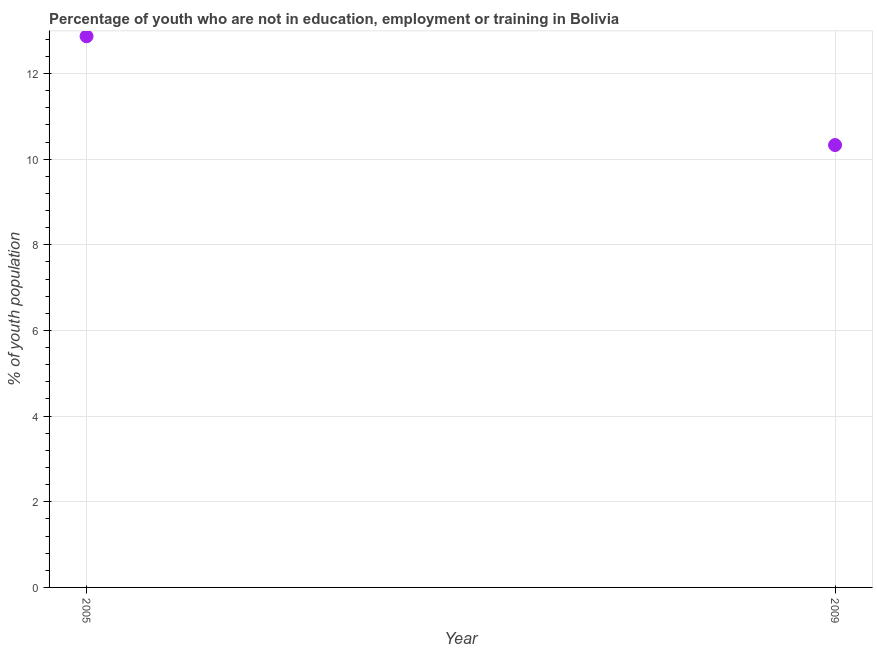What is the unemployed youth population in 2005?
Offer a very short reply. 12.87. Across all years, what is the maximum unemployed youth population?
Ensure brevity in your answer.  12.87. Across all years, what is the minimum unemployed youth population?
Your answer should be compact. 10.33. In which year was the unemployed youth population maximum?
Your response must be concise. 2005. What is the sum of the unemployed youth population?
Ensure brevity in your answer.  23.2. What is the difference between the unemployed youth population in 2005 and 2009?
Provide a short and direct response. 2.54. What is the average unemployed youth population per year?
Offer a very short reply. 11.6. What is the median unemployed youth population?
Offer a terse response. 11.6. Do a majority of the years between 2009 and 2005 (inclusive) have unemployed youth population greater than 7.6 %?
Keep it short and to the point. No. What is the ratio of the unemployed youth population in 2005 to that in 2009?
Provide a short and direct response. 1.25. Does the unemployed youth population monotonically increase over the years?
Offer a terse response. No. Does the graph contain grids?
Make the answer very short. Yes. What is the title of the graph?
Your response must be concise. Percentage of youth who are not in education, employment or training in Bolivia. What is the label or title of the X-axis?
Ensure brevity in your answer.  Year. What is the label or title of the Y-axis?
Offer a very short reply. % of youth population. What is the % of youth population in 2005?
Your answer should be very brief. 12.87. What is the % of youth population in 2009?
Make the answer very short. 10.33. What is the difference between the % of youth population in 2005 and 2009?
Your answer should be compact. 2.54. What is the ratio of the % of youth population in 2005 to that in 2009?
Keep it short and to the point. 1.25. 